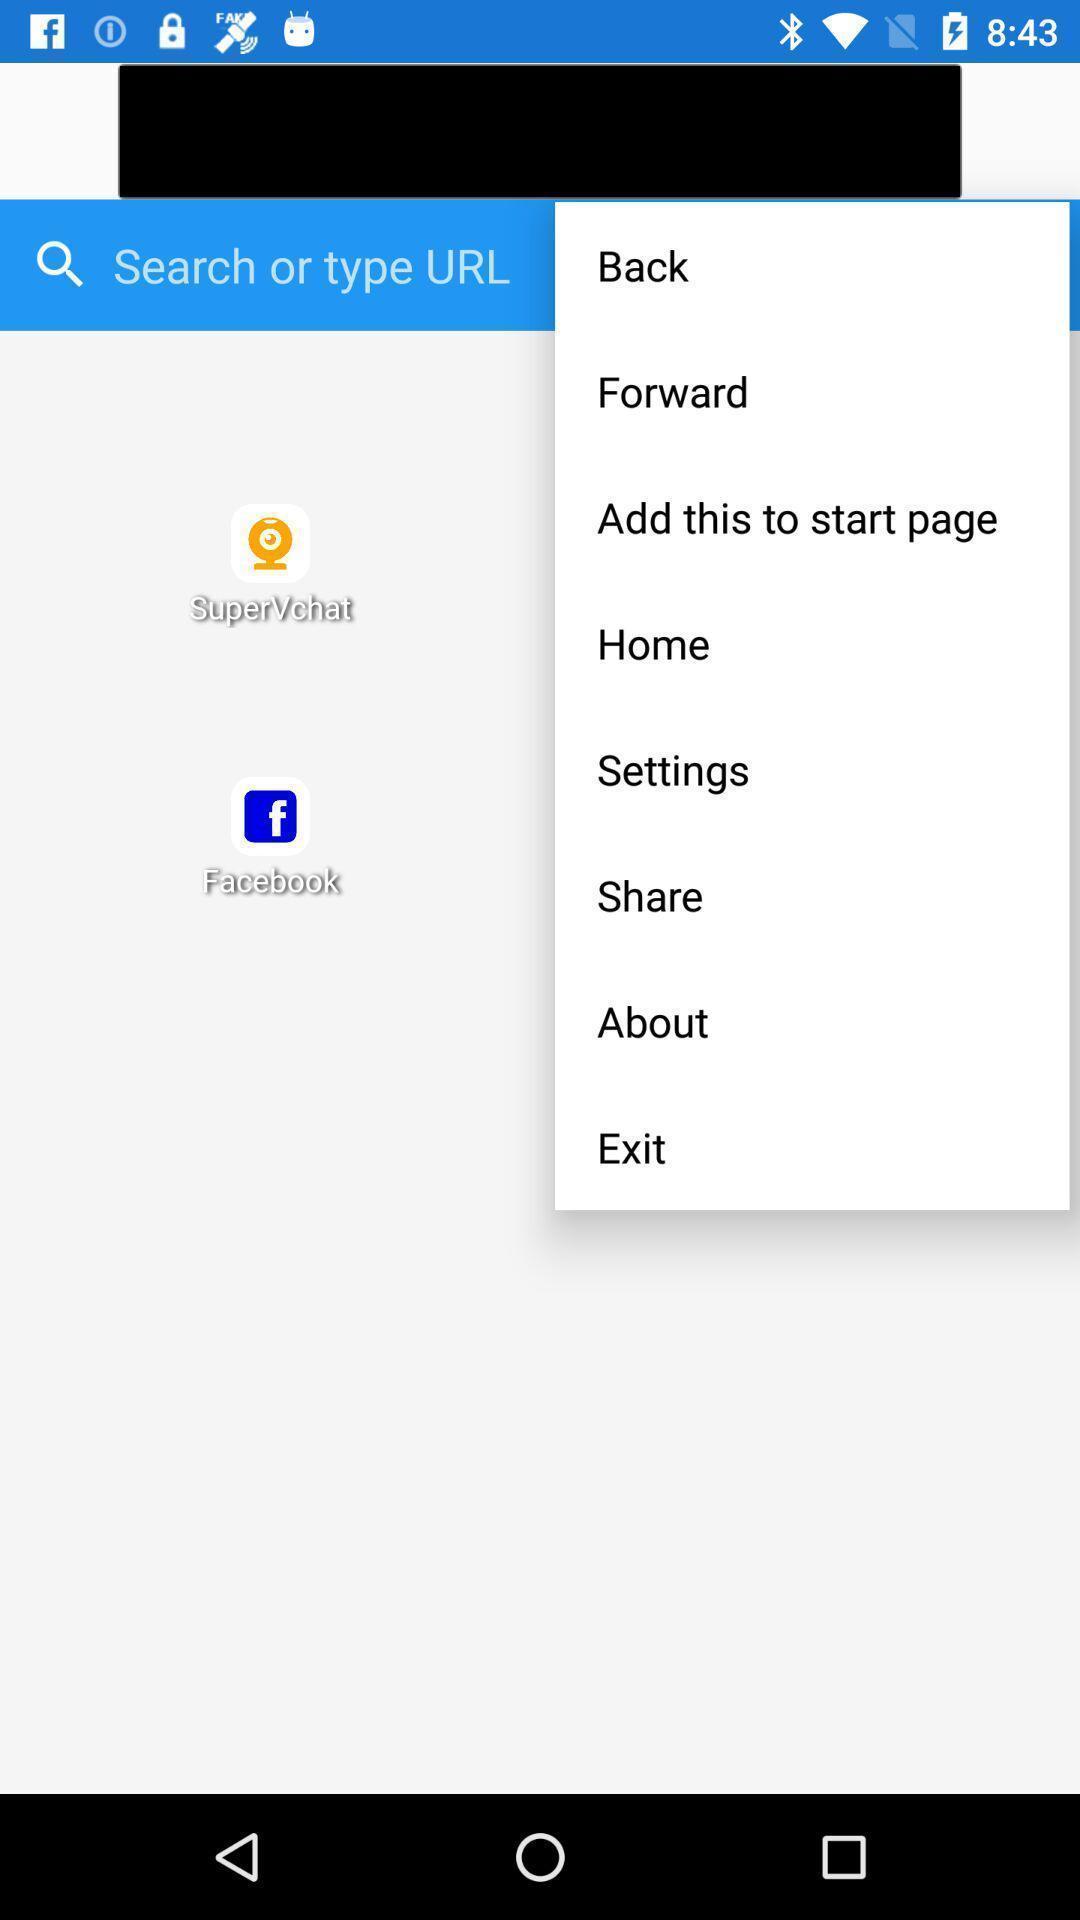Provide a textual representation of this image. Search bar with other various options. 